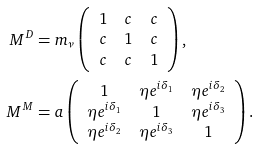<formula> <loc_0><loc_0><loc_500><loc_500>M ^ { D } & = m _ { \nu } \left ( \begin{array} { c c c } 1 & c & c \\ c & 1 & c \\ c & c & 1 \end{array} \right ) , \\ M ^ { M } & = a \left ( \begin{array} { c c c } 1 & \eta e ^ { i \delta _ { 1 } } & \eta e ^ { i \delta _ { 2 } } \\ \eta e ^ { i \delta _ { 1 } } & 1 & \eta e ^ { i \delta _ { 3 } } \\ \eta e ^ { i \delta _ { 2 } } & \eta e ^ { i \delta _ { 3 } } & 1 \end{array} \right ) .</formula> 